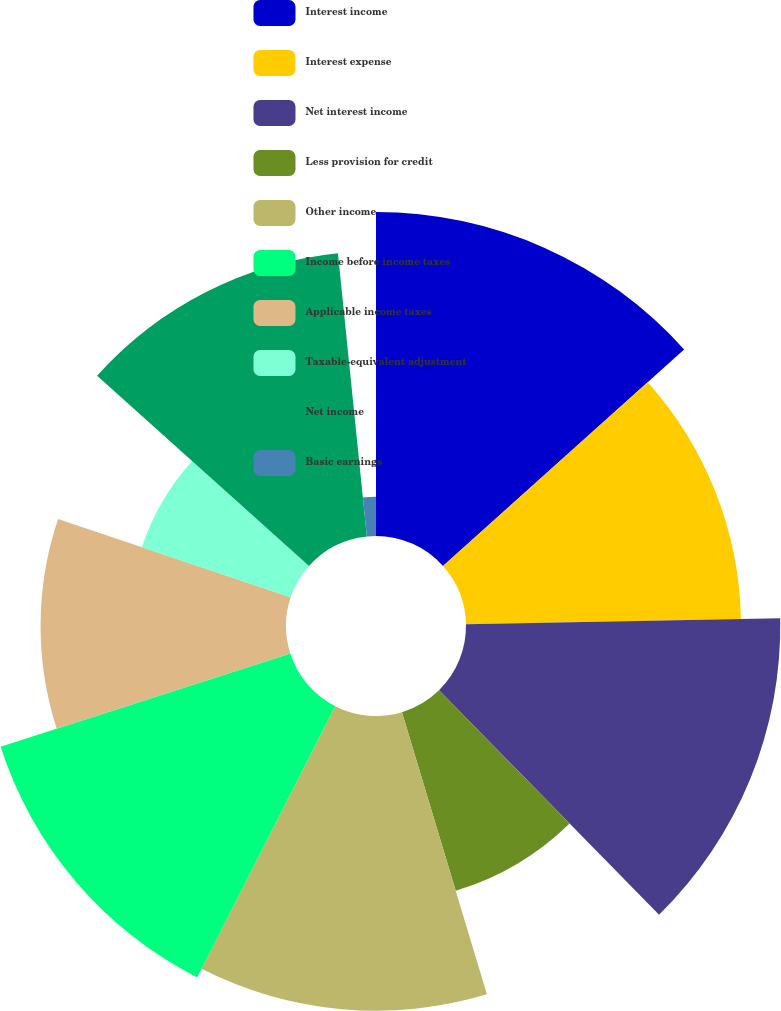Convert chart. <chart><loc_0><loc_0><loc_500><loc_500><pie_chart><fcel>Interest income<fcel>Interest expense<fcel>Net interest income<fcel>Less provision for credit<fcel>Other income<fcel>Income before income taxes<fcel>Applicable income taxes<fcel>Taxable-equivalent adjustment<fcel>Net income<fcel>Basic earnings<nl><fcel>13.36%<fcel>11.34%<fcel>12.96%<fcel>7.69%<fcel>12.15%<fcel>12.55%<fcel>10.12%<fcel>6.48%<fcel>11.74%<fcel>1.62%<nl></chart> 